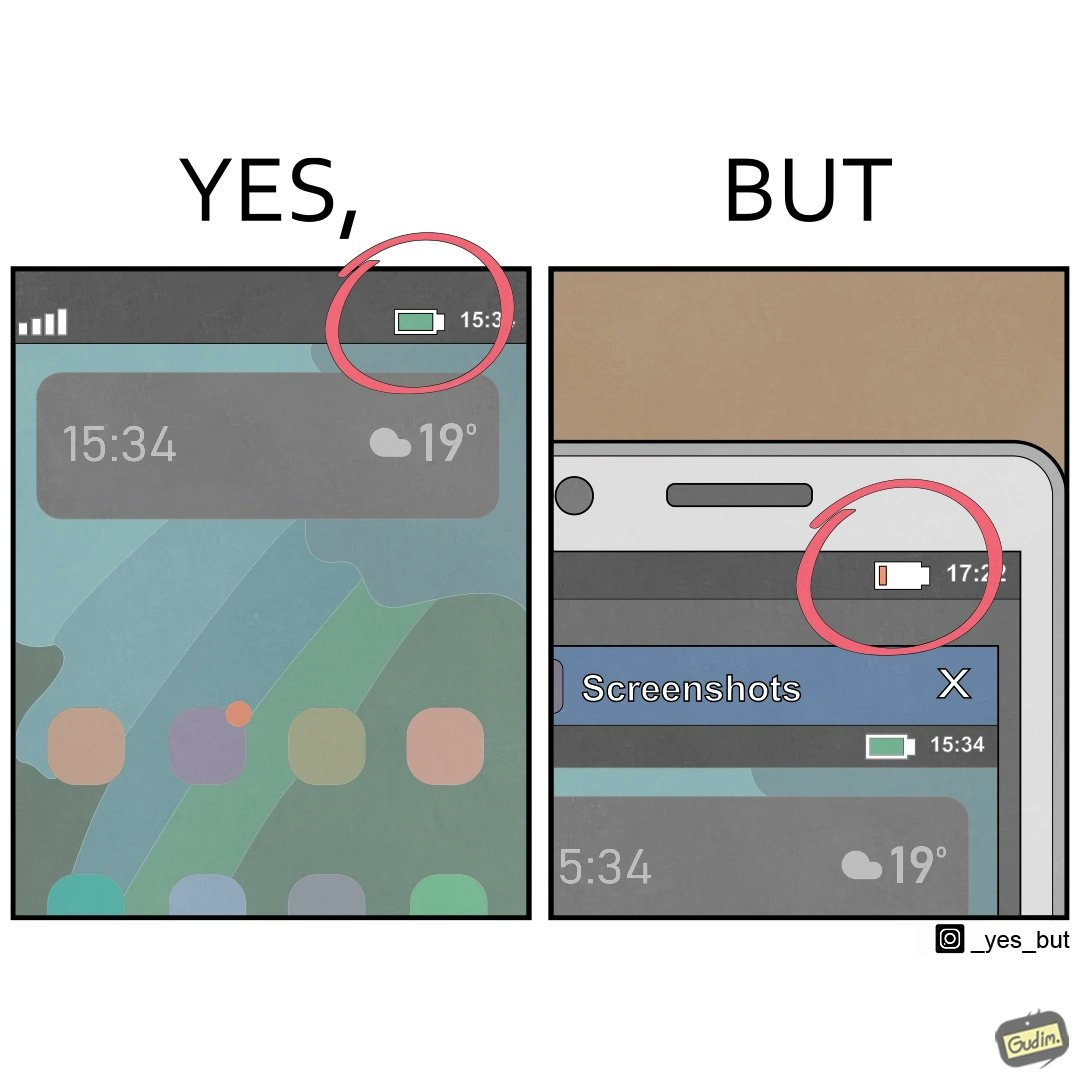Does this image contain satire or humor? Yes, this image is satirical. 